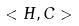<formula> <loc_0><loc_0><loc_500><loc_500>< H , C ></formula> 